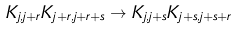Convert formula to latex. <formula><loc_0><loc_0><loc_500><loc_500>K _ { j , j + r } K _ { j + r , j + r + s } \rightarrow K _ { j , j + s } K _ { j + s , j + s + r }</formula> 